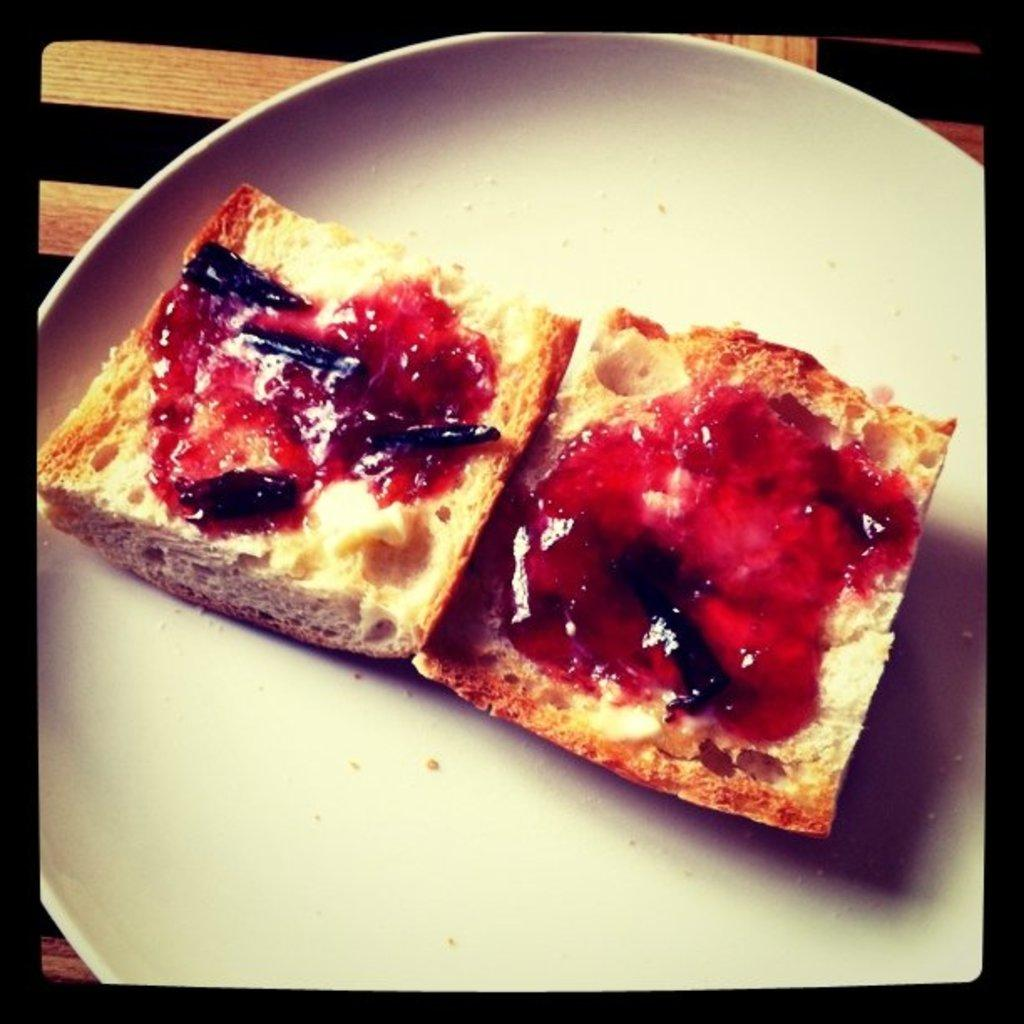What object is present on the plate in the image? There is a white plate in the image. What is on the plate? The plate contains food. Can you describe the appearance of the food on the plate? The food has brown and red colors. What type of thread is used to create the harbor scene in the image? There is no harbor scene or thread present in the image; it features a white plate with food. 